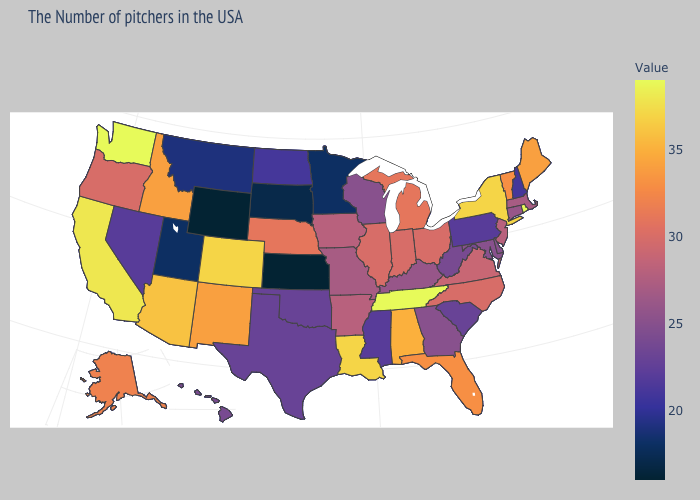Among the states that border North Dakota , which have the highest value?
Answer briefly. Montana. Among the states that border Nevada , which have the highest value?
Keep it brief. California. Which states have the lowest value in the Northeast?
Write a very short answer. New Hampshire. Is the legend a continuous bar?
Concise answer only. Yes. 